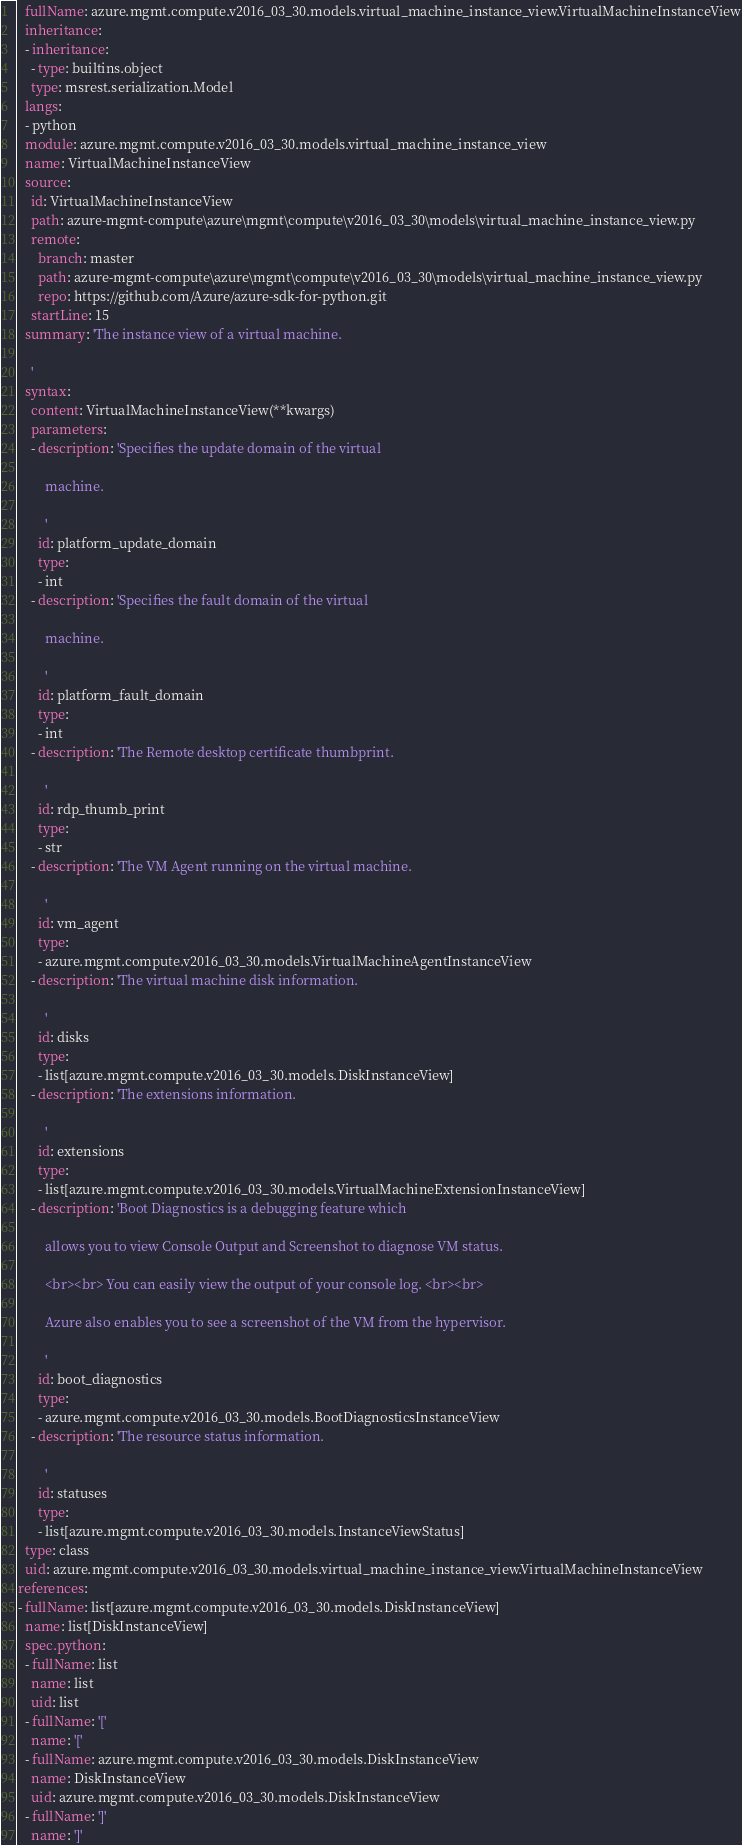Convert code to text. <code><loc_0><loc_0><loc_500><loc_500><_YAML_>  fullName: azure.mgmt.compute.v2016_03_30.models.virtual_machine_instance_view.VirtualMachineInstanceView
  inheritance:
  - inheritance:
    - type: builtins.object
    type: msrest.serialization.Model
  langs:
  - python
  module: azure.mgmt.compute.v2016_03_30.models.virtual_machine_instance_view
  name: VirtualMachineInstanceView
  source:
    id: VirtualMachineInstanceView
    path: azure-mgmt-compute\azure\mgmt\compute\v2016_03_30\models\virtual_machine_instance_view.py
    remote:
      branch: master
      path: azure-mgmt-compute\azure\mgmt\compute\v2016_03_30\models\virtual_machine_instance_view.py
      repo: https://github.com/Azure/azure-sdk-for-python.git
    startLine: 15
  summary: 'The instance view of a virtual machine.

    '
  syntax:
    content: VirtualMachineInstanceView(**kwargs)
    parameters:
    - description: 'Specifies the update domain of the virtual

        machine.

        '
      id: platform_update_domain
      type:
      - int
    - description: 'Specifies the fault domain of the virtual

        machine.

        '
      id: platform_fault_domain
      type:
      - int
    - description: 'The Remote desktop certificate thumbprint.

        '
      id: rdp_thumb_print
      type:
      - str
    - description: 'The VM Agent running on the virtual machine.

        '
      id: vm_agent
      type:
      - azure.mgmt.compute.v2016_03_30.models.VirtualMachineAgentInstanceView
    - description: 'The virtual machine disk information.

        '
      id: disks
      type:
      - list[azure.mgmt.compute.v2016_03_30.models.DiskInstanceView]
    - description: 'The extensions information.

        '
      id: extensions
      type:
      - list[azure.mgmt.compute.v2016_03_30.models.VirtualMachineExtensionInstanceView]
    - description: 'Boot Diagnostics is a debugging feature which

        allows you to view Console Output and Screenshot to diagnose VM status.

        <br><br> You can easily view the output of your console log. <br><br>

        Azure also enables you to see a screenshot of the VM from the hypervisor.

        '
      id: boot_diagnostics
      type:
      - azure.mgmt.compute.v2016_03_30.models.BootDiagnosticsInstanceView
    - description: 'The resource status information.

        '
      id: statuses
      type:
      - list[azure.mgmt.compute.v2016_03_30.models.InstanceViewStatus]
  type: class
  uid: azure.mgmt.compute.v2016_03_30.models.virtual_machine_instance_view.VirtualMachineInstanceView
references:
- fullName: list[azure.mgmt.compute.v2016_03_30.models.DiskInstanceView]
  name: list[DiskInstanceView]
  spec.python:
  - fullName: list
    name: list
    uid: list
  - fullName: '['
    name: '['
  - fullName: azure.mgmt.compute.v2016_03_30.models.DiskInstanceView
    name: DiskInstanceView
    uid: azure.mgmt.compute.v2016_03_30.models.DiskInstanceView
  - fullName: ']'
    name: ']'</code> 